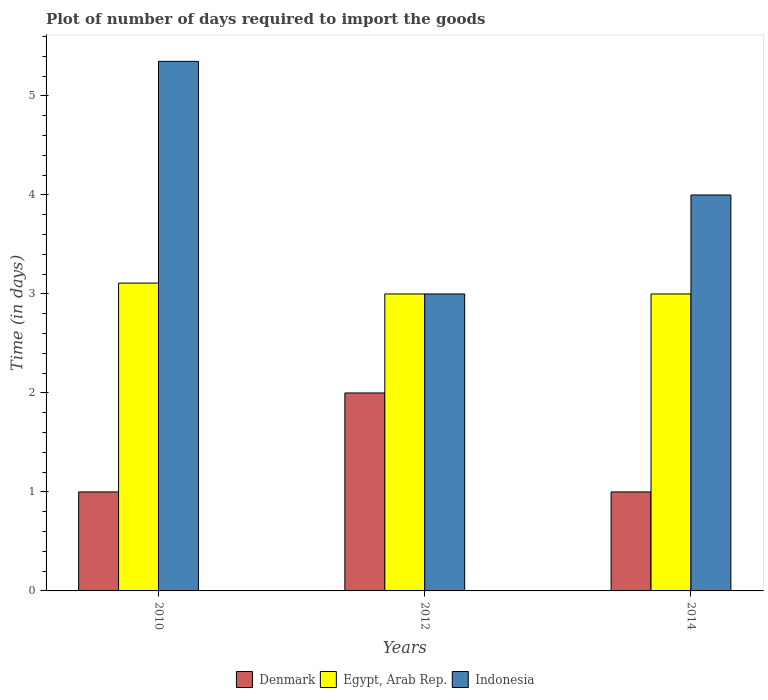How many bars are there on the 2nd tick from the right?
Provide a short and direct response. 3. In how many cases, is the number of bars for a given year not equal to the number of legend labels?
Ensure brevity in your answer.  0. What is the time required to import goods in Egypt, Arab Rep. in 2014?
Your answer should be compact. 3. Across all years, what is the maximum time required to import goods in Egypt, Arab Rep.?
Provide a succinct answer. 3.11. In which year was the time required to import goods in Denmark maximum?
Offer a terse response. 2012. In which year was the time required to import goods in Denmark minimum?
Your response must be concise. 2010. What is the total time required to import goods in Indonesia in the graph?
Make the answer very short. 12.35. What is the difference between the time required to import goods in Denmark in 2010 and that in 2012?
Offer a terse response. -1. What is the average time required to import goods in Denmark per year?
Give a very brief answer. 1.33. What is the ratio of the time required to import goods in Denmark in 2010 to that in 2012?
Your answer should be compact. 0.5. What is the difference between the highest and the second highest time required to import goods in Egypt, Arab Rep.?
Provide a short and direct response. 0.11. What is the difference between the highest and the lowest time required to import goods in Indonesia?
Keep it short and to the point. 2.35. In how many years, is the time required to import goods in Indonesia greater than the average time required to import goods in Indonesia taken over all years?
Provide a short and direct response. 1. What does the 3rd bar from the left in 2010 represents?
Your response must be concise. Indonesia. What does the 2nd bar from the right in 2012 represents?
Your answer should be very brief. Egypt, Arab Rep. Is it the case that in every year, the sum of the time required to import goods in Denmark and time required to import goods in Egypt, Arab Rep. is greater than the time required to import goods in Indonesia?
Your response must be concise. No. Are all the bars in the graph horizontal?
Offer a very short reply. No. What is the difference between two consecutive major ticks on the Y-axis?
Offer a terse response. 1. Are the values on the major ticks of Y-axis written in scientific E-notation?
Keep it short and to the point. No. Where does the legend appear in the graph?
Give a very brief answer. Bottom center. What is the title of the graph?
Make the answer very short. Plot of number of days required to import the goods. Does "Europe(all income levels)" appear as one of the legend labels in the graph?
Your answer should be compact. No. What is the label or title of the Y-axis?
Ensure brevity in your answer.  Time (in days). What is the Time (in days) in Egypt, Arab Rep. in 2010?
Offer a very short reply. 3.11. What is the Time (in days) of Indonesia in 2010?
Ensure brevity in your answer.  5.35. What is the Time (in days) in Denmark in 2012?
Make the answer very short. 2. What is the Time (in days) of Egypt, Arab Rep. in 2012?
Offer a very short reply. 3. What is the Time (in days) of Denmark in 2014?
Provide a short and direct response. 1. What is the Time (in days) in Indonesia in 2014?
Offer a terse response. 4. Across all years, what is the maximum Time (in days) of Egypt, Arab Rep.?
Give a very brief answer. 3.11. Across all years, what is the maximum Time (in days) in Indonesia?
Your answer should be compact. 5.35. Across all years, what is the minimum Time (in days) in Denmark?
Offer a very short reply. 1. What is the total Time (in days) in Egypt, Arab Rep. in the graph?
Ensure brevity in your answer.  9.11. What is the total Time (in days) of Indonesia in the graph?
Keep it short and to the point. 12.35. What is the difference between the Time (in days) in Egypt, Arab Rep. in 2010 and that in 2012?
Offer a terse response. 0.11. What is the difference between the Time (in days) in Indonesia in 2010 and that in 2012?
Provide a succinct answer. 2.35. What is the difference between the Time (in days) of Egypt, Arab Rep. in 2010 and that in 2014?
Give a very brief answer. 0.11. What is the difference between the Time (in days) of Indonesia in 2010 and that in 2014?
Offer a terse response. 1.35. What is the difference between the Time (in days) of Indonesia in 2012 and that in 2014?
Make the answer very short. -1. What is the difference between the Time (in days) of Egypt, Arab Rep. in 2010 and the Time (in days) of Indonesia in 2012?
Your response must be concise. 0.11. What is the difference between the Time (in days) of Denmark in 2010 and the Time (in days) of Egypt, Arab Rep. in 2014?
Your answer should be compact. -2. What is the difference between the Time (in days) in Egypt, Arab Rep. in 2010 and the Time (in days) in Indonesia in 2014?
Give a very brief answer. -0.89. What is the difference between the Time (in days) of Denmark in 2012 and the Time (in days) of Egypt, Arab Rep. in 2014?
Provide a succinct answer. -1. What is the difference between the Time (in days) of Denmark in 2012 and the Time (in days) of Indonesia in 2014?
Keep it short and to the point. -2. What is the average Time (in days) of Egypt, Arab Rep. per year?
Keep it short and to the point. 3.04. What is the average Time (in days) of Indonesia per year?
Make the answer very short. 4.12. In the year 2010, what is the difference between the Time (in days) of Denmark and Time (in days) of Egypt, Arab Rep.?
Provide a short and direct response. -2.11. In the year 2010, what is the difference between the Time (in days) in Denmark and Time (in days) in Indonesia?
Keep it short and to the point. -4.35. In the year 2010, what is the difference between the Time (in days) in Egypt, Arab Rep. and Time (in days) in Indonesia?
Your response must be concise. -2.24. In the year 2012, what is the difference between the Time (in days) in Denmark and Time (in days) in Egypt, Arab Rep.?
Offer a terse response. -1. In the year 2012, what is the difference between the Time (in days) in Denmark and Time (in days) in Indonesia?
Keep it short and to the point. -1. In the year 2012, what is the difference between the Time (in days) in Egypt, Arab Rep. and Time (in days) in Indonesia?
Ensure brevity in your answer.  0. In the year 2014, what is the difference between the Time (in days) in Denmark and Time (in days) in Indonesia?
Keep it short and to the point. -3. In the year 2014, what is the difference between the Time (in days) in Egypt, Arab Rep. and Time (in days) in Indonesia?
Offer a very short reply. -1. What is the ratio of the Time (in days) in Egypt, Arab Rep. in 2010 to that in 2012?
Your answer should be very brief. 1.04. What is the ratio of the Time (in days) in Indonesia in 2010 to that in 2012?
Give a very brief answer. 1.78. What is the ratio of the Time (in days) of Egypt, Arab Rep. in 2010 to that in 2014?
Give a very brief answer. 1.04. What is the ratio of the Time (in days) in Indonesia in 2010 to that in 2014?
Your answer should be very brief. 1.34. What is the ratio of the Time (in days) in Egypt, Arab Rep. in 2012 to that in 2014?
Make the answer very short. 1. What is the ratio of the Time (in days) of Indonesia in 2012 to that in 2014?
Keep it short and to the point. 0.75. What is the difference between the highest and the second highest Time (in days) in Denmark?
Your response must be concise. 1. What is the difference between the highest and the second highest Time (in days) in Egypt, Arab Rep.?
Provide a succinct answer. 0.11. What is the difference between the highest and the second highest Time (in days) of Indonesia?
Your response must be concise. 1.35. What is the difference between the highest and the lowest Time (in days) of Egypt, Arab Rep.?
Provide a succinct answer. 0.11. What is the difference between the highest and the lowest Time (in days) of Indonesia?
Offer a very short reply. 2.35. 